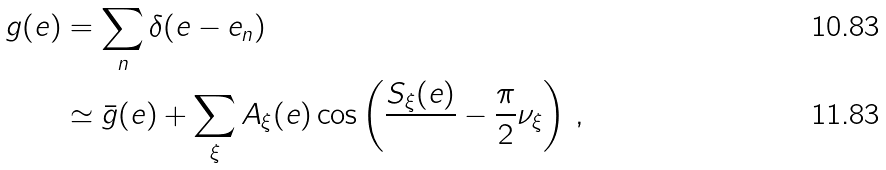Convert formula to latex. <formula><loc_0><loc_0><loc_500><loc_500>g ( e ) & = \sum _ { n } \delta ( e - e _ { n } ) \\ & \simeq \bar { g } ( e ) + \sum _ { \xi } A _ { \xi } ( e ) \cos \left ( \frac { S _ { \xi } ( e ) } { } - \frac { \pi } { 2 } \nu _ { \xi } \right ) \, ,</formula> 